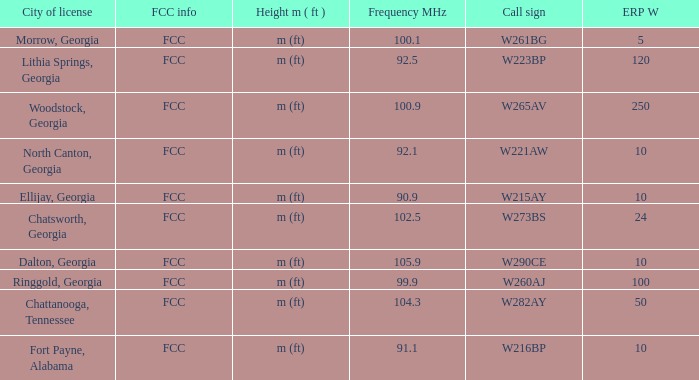What is the number of Frequency MHz in woodstock, georgia? 100.9. 